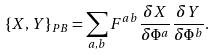<formula> <loc_0><loc_0><loc_500><loc_500>\{ X , Y \} _ { P B } = \sum _ { a , b } F ^ { a b } \frac { \delta X } { \delta \Phi ^ { a } } \frac { \delta Y } { \delta \Phi ^ { b } } .</formula> 